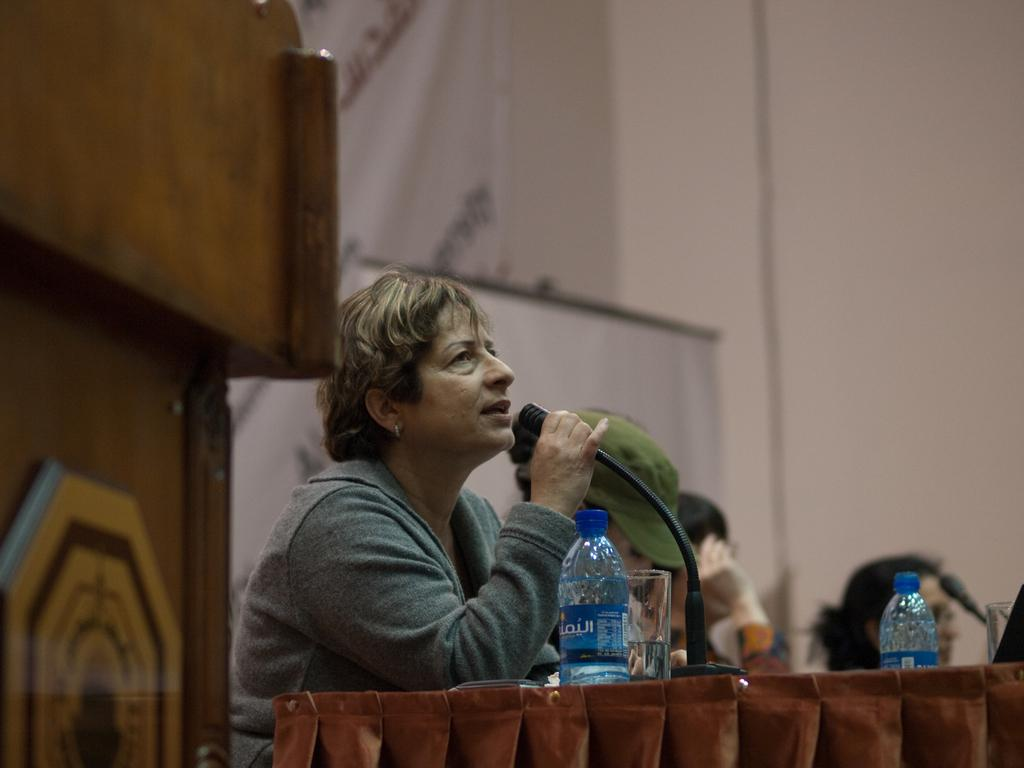Who is the main subject in the image? There is a lady person in the image. What is the lady person holding in her left hand? The lady person is holding a microphone in her left hand. What can be seen on the table in the image? There is a bottle on the table. What is happening in the background of the image? There is a group of persons in the background of the image. What type of bears can be seen playing in the garden in the image? There are no bears or gardens present in the image. 